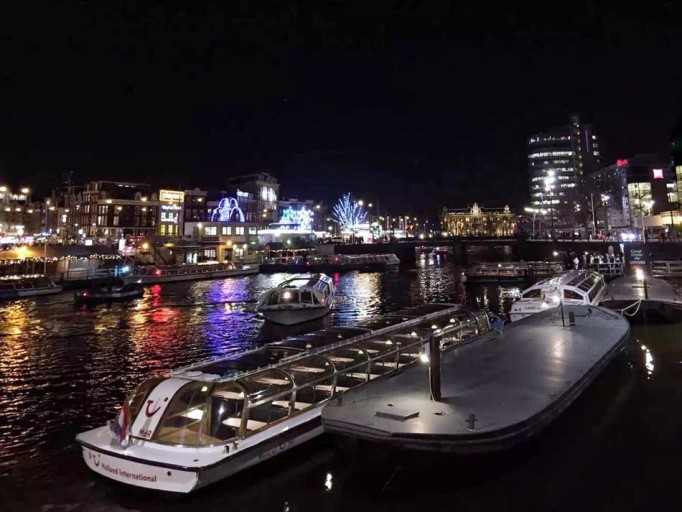Are there any prominent buildings or landmarks visible in the background? While specific landmarks aren’t clearly discernible, the illuminated facades and varied architecture suggest a bustling urban waterfront with a mix of commercial and possibly cultural buildings. 